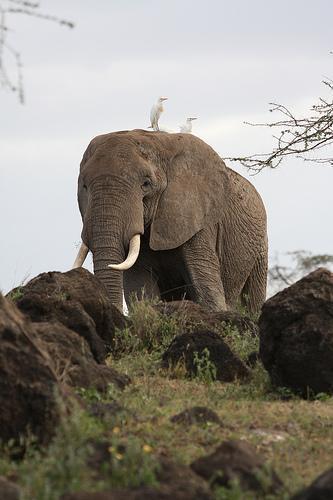How many elephants are there?
Give a very brief answer. 1. How many birds are on the elephant's back?
Give a very brief answer. 3. How many tusks does the elephant have?
Give a very brief answer. 2. 